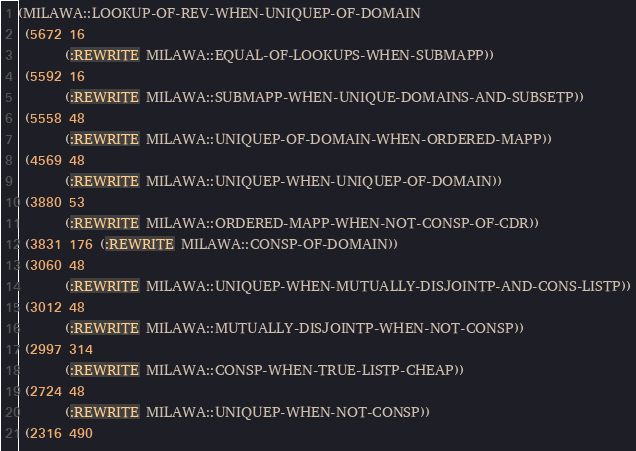<code> <loc_0><loc_0><loc_500><loc_500><_Lisp_>(MILAWA::LOOKUP-OF-REV-WHEN-UNIQUEP-OF-DOMAIN
 (5672 16
       (:REWRITE MILAWA::EQUAL-OF-LOOKUPS-WHEN-SUBMAPP))
 (5592 16
       (:REWRITE MILAWA::SUBMAPP-WHEN-UNIQUE-DOMAINS-AND-SUBSETP))
 (5558 48
       (:REWRITE MILAWA::UNIQUEP-OF-DOMAIN-WHEN-ORDERED-MAPP))
 (4569 48
       (:REWRITE MILAWA::UNIQUEP-WHEN-UNIQUEP-OF-DOMAIN))
 (3880 53
       (:REWRITE MILAWA::ORDERED-MAPP-WHEN-NOT-CONSP-OF-CDR))
 (3831 176 (:REWRITE MILAWA::CONSP-OF-DOMAIN))
 (3060 48
       (:REWRITE MILAWA::UNIQUEP-WHEN-MUTUALLY-DISJOINTP-AND-CONS-LISTP))
 (3012 48
       (:REWRITE MILAWA::MUTUALLY-DISJOINTP-WHEN-NOT-CONSP))
 (2997 314
       (:REWRITE MILAWA::CONSP-WHEN-TRUE-LISTP-CHEAP))
 (2724 48
       (:REWRITE MILAWA::UNIQUEP-WHEN-NOT-CONSP))
 (2316 490</code> 